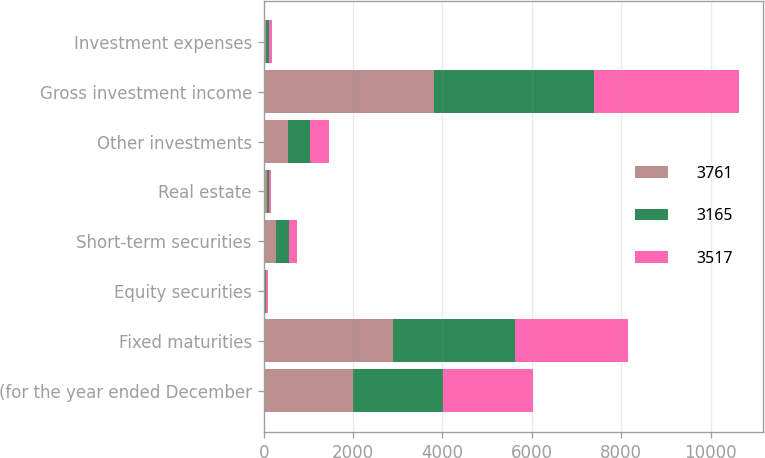Convert chart to OTSL. <chart><loc_0><loc_0><loc_500><loc_500><stacked_bar_chart><ecel><fcel>(for the year ended December<fcel>Fixed maturities<fcel>Equity securities<fcel>Short-term securities<fcel>Real estate<fcel>Other investments<fcel>Gross investment income<fcel>Investment expenses<nl><fcel>3761<fcel>2007<fcel>2893<fcel>29<fcel>279<fcel>64<fcel>555<fcel>3820<fcel>59<nl><fcel>3165<fcel>2006<fcel>2738<fcel>30<fcel>285<fcel>46<fcel>481<fcel>3580<fcel>63<nl><fcel>3517<fcel>2005<fcel>2530<fcel>41<fcel>182<fcel>58<fcel>427<fcel>3238<fcel>73<nl></chart> 